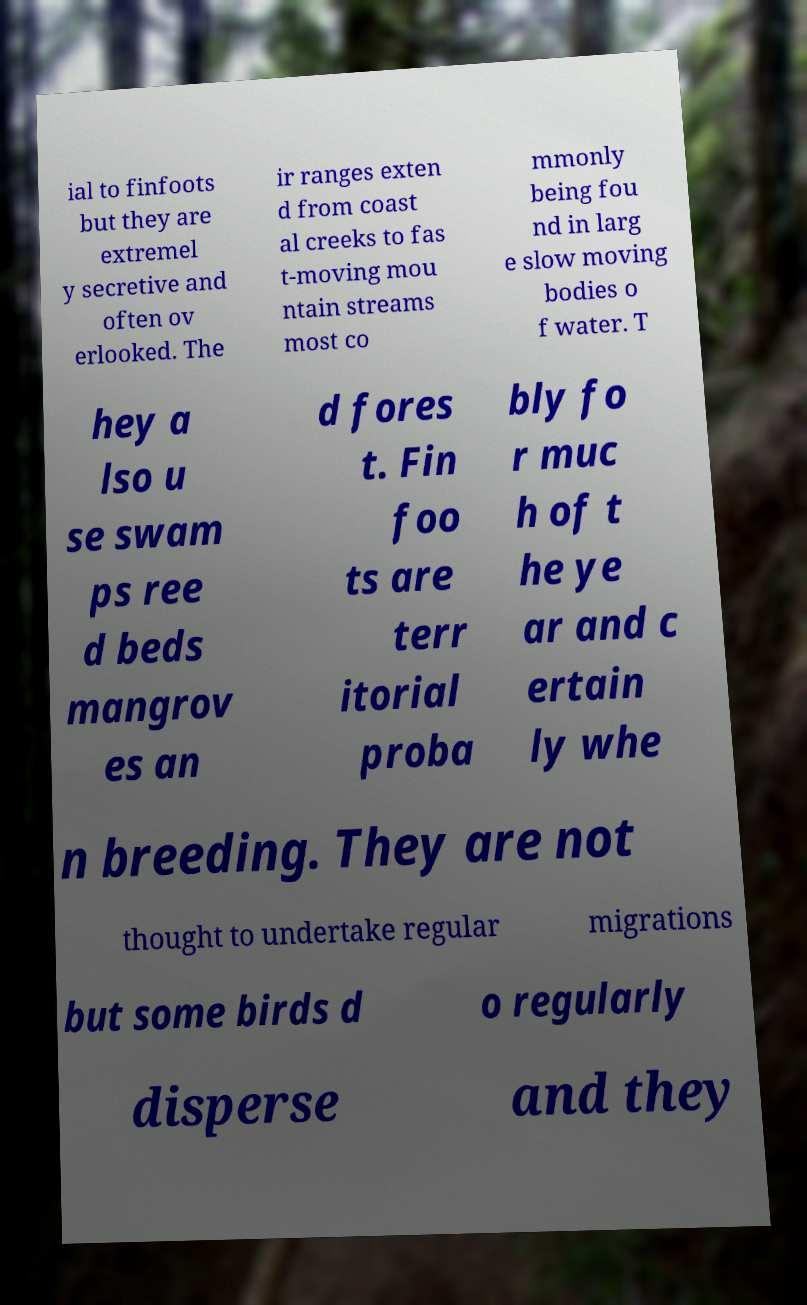Please identify and transcribe the text found in this image. ial to finfoots but they are extremel y secretive and often ov erlooked. The ir ranges exten d from coast al creeks to fas t-moving mou ntain streams most co mmonly being fou nd in larg e slow moving bodies o f water. T hey a lso u se swam ps ree d beds mangrov es an d fores t. Fin foo ts are terr itorial proba bly fo r muc h of t he ye ar and c ertain ly whe n breeding. They are not thought to undertake regular migrations but some birds d o regularly disperse and they 